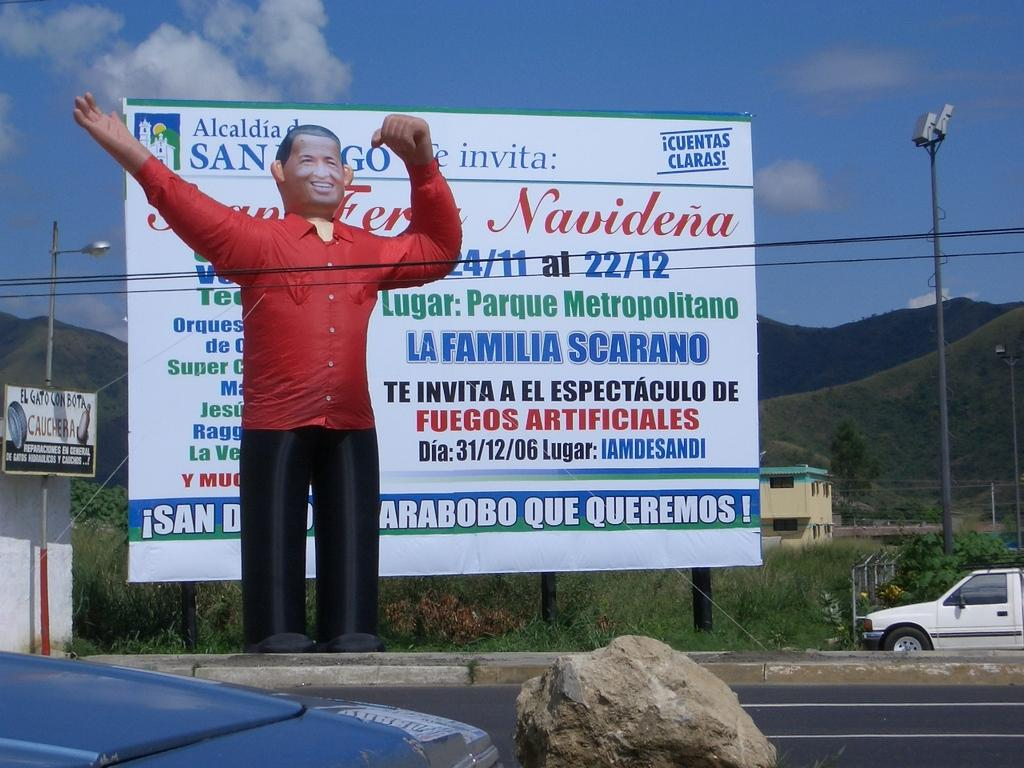<image>
Share a concise interpretation of the image provided. the word Navidena is on the sign that is outside 